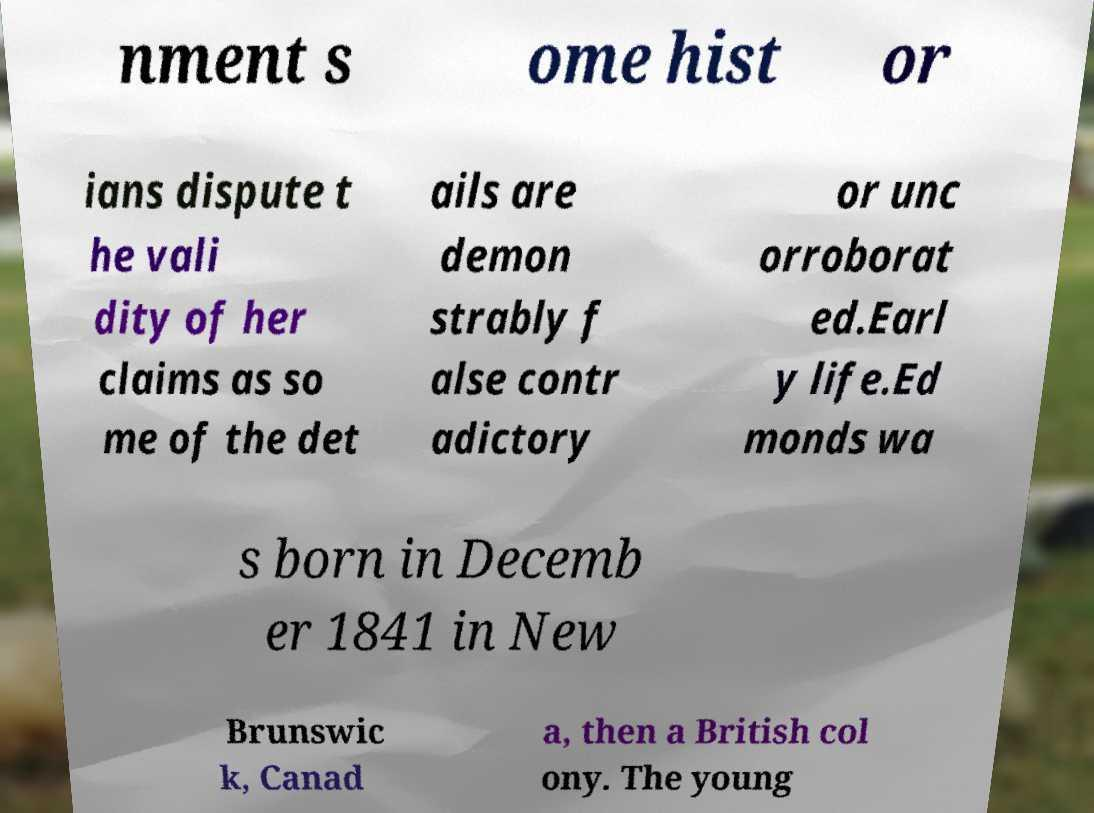Please identify and transcribe the text found in this image. nment s ome hist or ians dispute t he vali dity of her claims as so me of the det ails are demon strably f alse contr adictory or unc orroborat ed.Earl y life.Ed monds wa s born in Decemb er 1841 in New Brunswic k, Canad a, then a British col ony. The young 